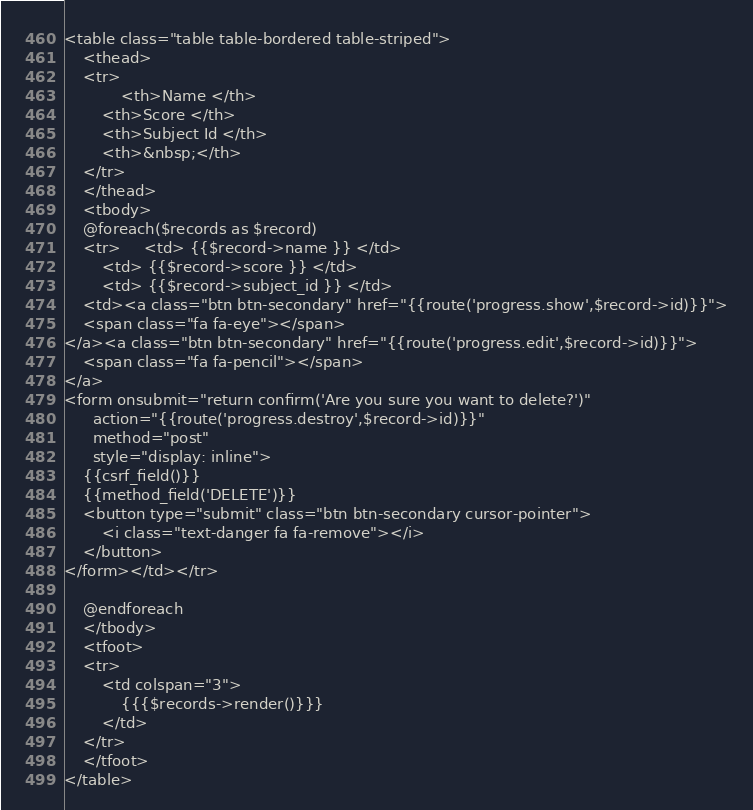<code> <loc_0><loc_0><loc_500><loc_500><_PHP_><table class="table table-bordered table-striped">
    <thead>
    <tr>
    		<th>Name </th>
		<th>Score </th>
		<th>Subject Id </th>
		<th>&nbsp;</th>
    </tr>
    </thead>
    <tbody>
    @foreach($records as $record)
    <tr>	 	<td> {{$record->name }} </td>
	 	<td> {{$record->score }} </td>
	 	<td> {{$record->subject_id }} </td>
	<td><a class="btn btn-secondary" href="{{route('progress.show',$record->id)}}">
    <span class="fa fa-eye"></span>
</a><a class="btn btn-secondary" href="{{route('progress.edit',$record->id)}}">
    <span class="fa fa-pencil"></span>
</a>
<form onsubmit="return confirm('Are you sure you want to delete?')"
      action="{{route('progress.destroy',$record->id)}}"
      method="post"
      style="display: inline">
    {{csrf_field()}}
    {{method_field('DELETE')}}
    <button type="submit" class="btn btn-secondary cursor-pointer">
        <i class="text-danger fa fa-remove"></i>
    </button>
</form></td></tr>

    @endforeach
    </tbody>
    <tfoot>
    <tr>
        <td colspan="3">
            {{{$records->render()}}}
        </td>
    </tr>
    </tfoot>
</table></code> 